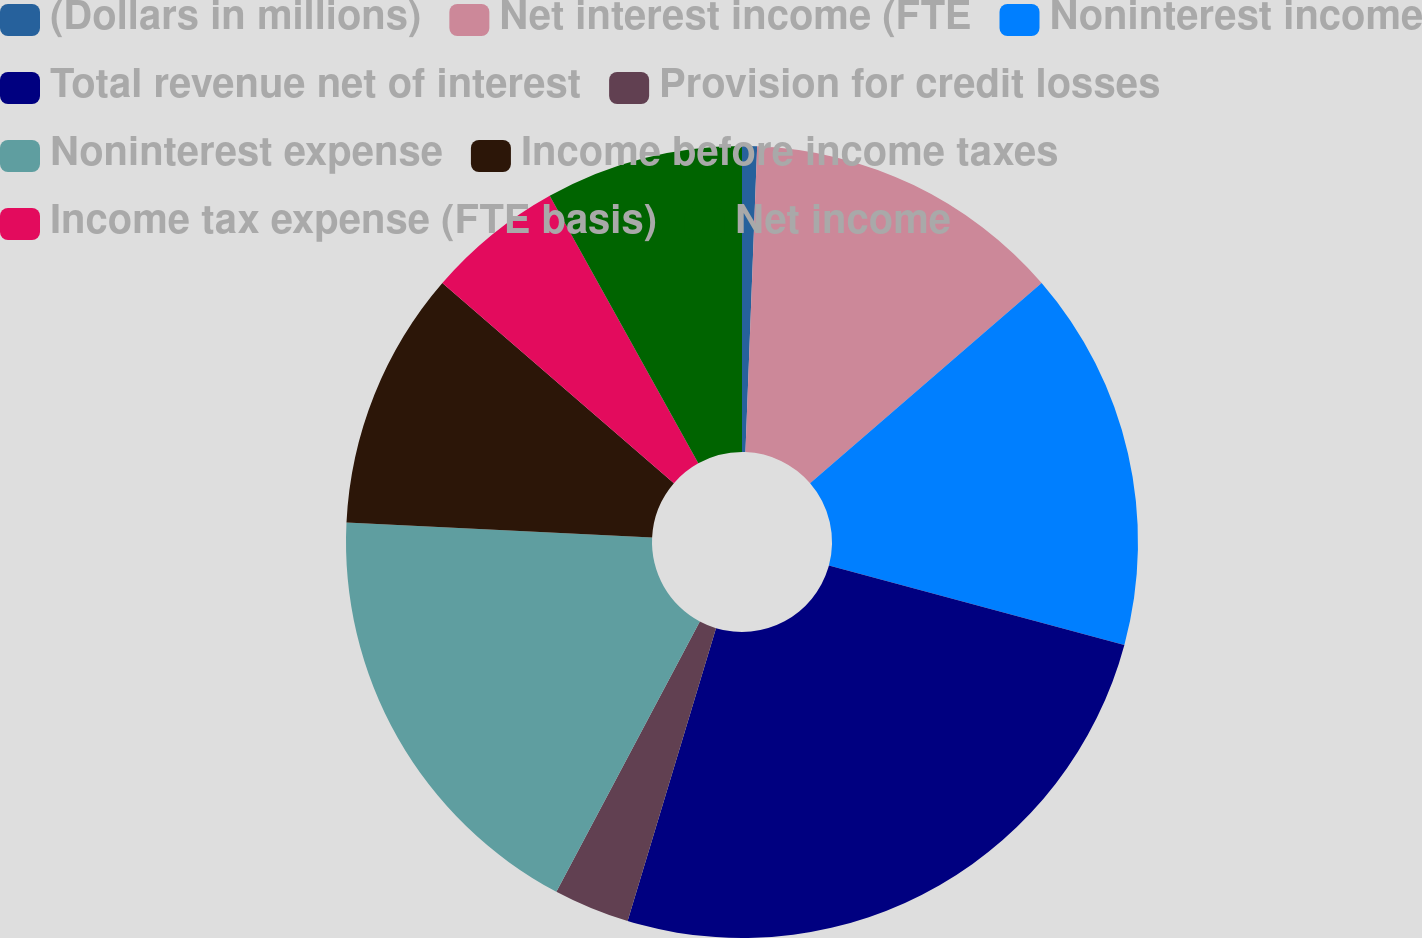Convert chart to OTSL. <chart><loc_0><loc_0><loc_500><loc_500><pie_chart><fcel>(Dollars in millions)<fcel>Net interest income (FTE<fcel>Noninterest income<fcel>Total revenue net of interest<fcel>Provision for credit losses<fcel>Noninterest expense<fcel>Income before income taxes<fcel>Income tax expense (FTE basis)<fcel>Net income<nl><fcel>0.61%<fcel>13.05%<fcel>15.53%<fcel>25.48%<fcel>3.1%<fcel>18.02%<fcel>10.56%<fcel>5.59%<fcel>8.07%<nl></chart> 